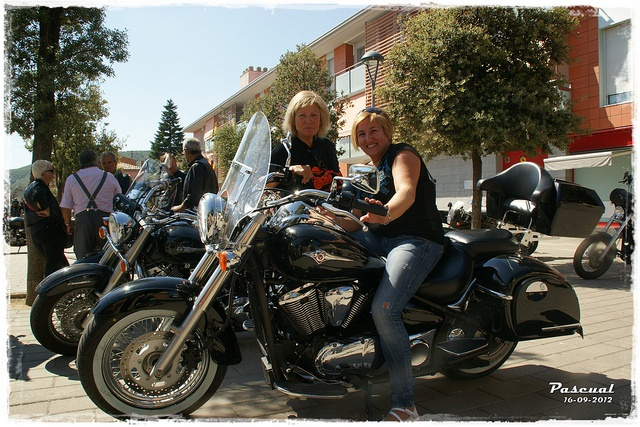Describe the objects in this image and their specific colors. I can see motorcycle in white, black, gray, and darkgray tones, motorcycle in white, black, gray, and darkgray tones, people in white, black, maroon, and gray tones, people in white, black, maroon, and tan tones, and people in white, black, maroon, and gray tones in this image. 